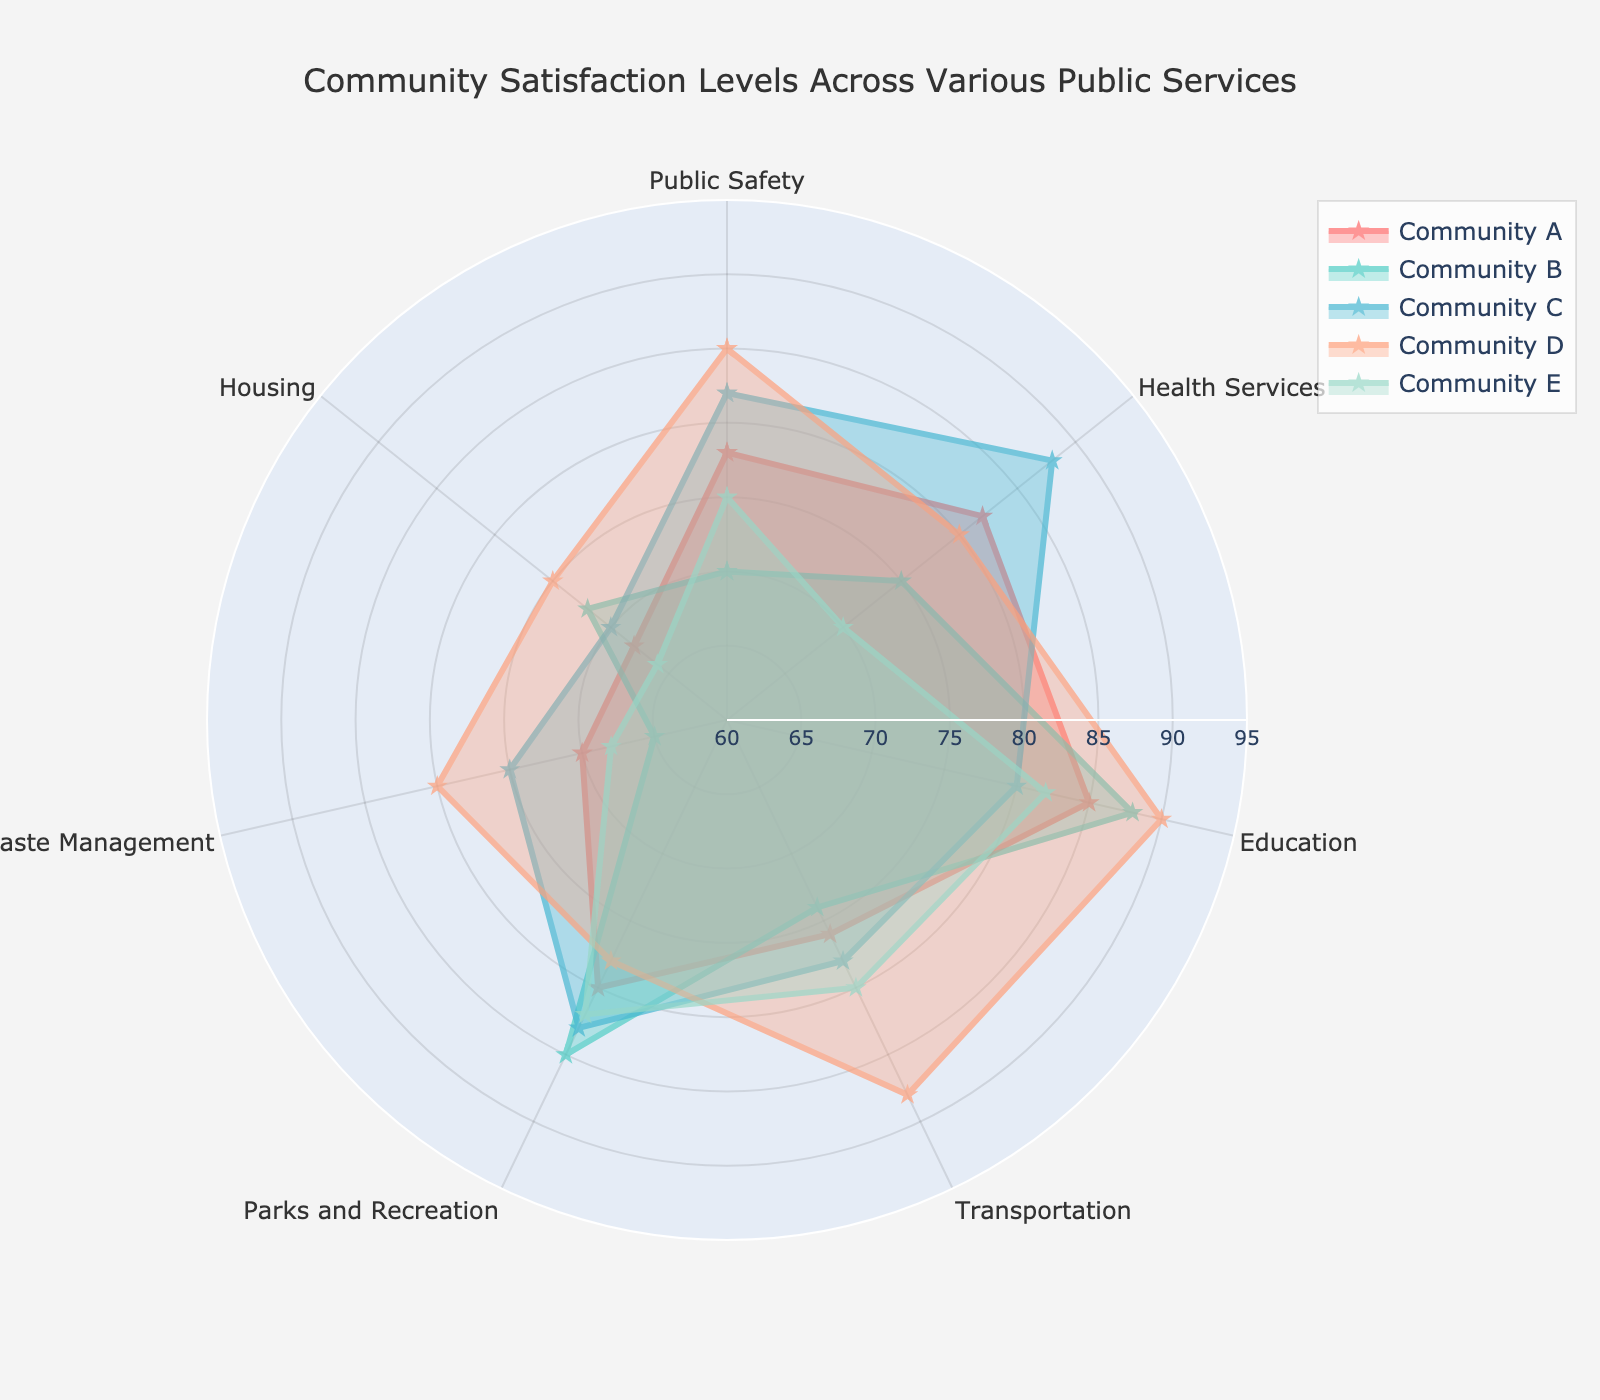What is the title of the radar chart? The title of the radar chart is clearly visible at the top of the image. It reads "Community Satisfaction Levels Across Various Public Services".
Answer: Community Satisfaction Levels Across Various Public Services How many communities are represented in the radar chart? There are five distinct traces or shapes in the radar chart, each labeled with a community name. The communities are labeled as Community A, Community B, Community C, Community D, and Community E.
Answer: 5 Which community has the highest satisfaction level in Education? By looking at the 'Education' axis, Community D has the highest value plotted around 90, which is higher than any other community.
Answer: Community D What is the satisfaction score of Community A in Health Services? By focusing on the 'Health Services' axis, the plotted point for Community A aligns with the value 82.
Answer: 82 Which two communities have the closest satisfaction levels in Public Safety? Observing the 'Public Safety' axis, Community C and Community D both have closely plotted points around 82 and 85, respectively. The gap between their values is small compared to other gaps.
Answer: Community C and Community D Which community has the lowest satisfaction level in Waste Management? By examining the 'Waste Management' axis, the plotted point for Community E is around 68, which is lower than the plotted points for any other community.
Answer: Community E What is the average satisfaction level of Community B across all public services? To find the average, sum all satisfaction levels for Community B (70 + 75 + 88 + 74 + 85 + 65 + 72) which equals 529. Divide this sum by the number of categories (7), resulting in an average of 75.57.
Answer: 75.57 Which community shows the most balanced (least variance) satisfaction across all services? By visually inspecting the shapes and how evenly distributed their values are across the axes, Community C seems the most balanced as the values are consistently clustered near the center of the radar chart.
Answer: Community C What is the range of satisfaction scores for Community D in Transportation? The plotted point corresponding to 'Transportation' for Community D is around 88. Since the range typically represents the spread of data, it doesn't change without additional points. Instead, simply state the satisfaction score.
Answer: 88 Compare the satisfaction levels in Housing for Communities A and E. Which one is higher, and by how much? Community A has a value of 68 for Housing, while Community E has a value of 66. Subtract 66 from 68 to get the difference, which is 2. Thus, Community A’s satisfaction in Housing is 2 units higher than Community E’s.
Answer: Community A, by 2 